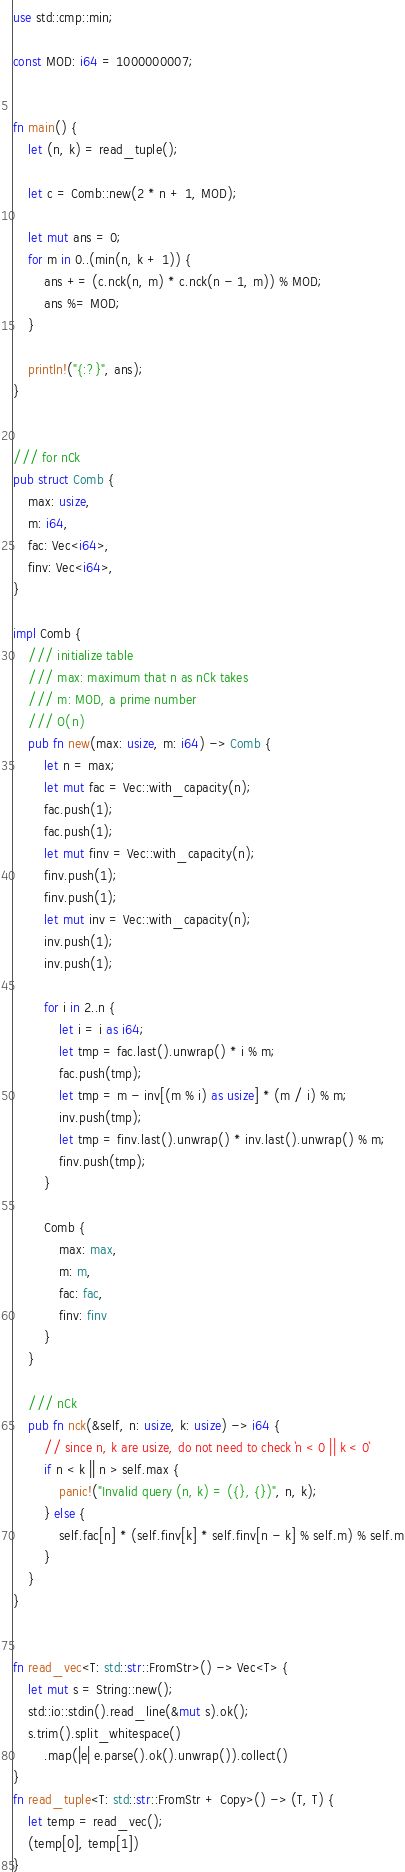<code> <loc_0><loc_0><loc_500><loc_500><_Rust_>use std::cmp::min;

const MOD: i64 = 1000000007;


fn main() {
    let (n, k) = read_tuple();

    let c = Comb::new(2 * n + 1, MOD);

    let mut ans = 0;
    for m in 0..(min(n, k + 1)) {
        ans += (c.nck(n, m) * c.nck(n - 1, m)) % MOD;
        ans %= MOD;
    }
    
    println!("{:?}", ans);
}


/// for nCk
pub struct Comb {
    max: usize,
    m: i64,
    fac: Vec<i64>,
    finv: Vec<i64>,
}

impl Comb {
    /// initialize table 
    /// max: maximum that n as nCk takes
    /// m: MOD, a prime number
    /// O(n)
    pub fn new(max: usize, m: i64) -> Comb {
        let n = max;
        let mut fac = Vec::with_capacity(n);
        fac.push(1);
        fac.push(1);
        let mut finv = Vec::with_capacity(n);
        finv.push(1);
        finv.push(1);
        let mut inv = Vec::with_capacity(n);
        inv.push(1);
        inv.push(1);

        for i in 2..n {
            let i = i as i64;
            let tmp = fac.last().unwrap() * i % m;
            fac.push(tmp);
            let tmp = m - inv[(m % i) as usize] * (m / i) % m;
            inv.push(tmp);
            let tmp = finv.last().unwrap() * inv.last().unwrap() % m;
            finv.push(tmp);
        }

        Comb {
            max: max,
            m: m,
            fac: fac,
            finv: finv
        }
    }

    /// nCk
    pub fn nck(&self, n: usize, k: usize) -> i64 {
        // since n, k are usize, do not need to check `n < 0 || k < 0`
        if n < k || n > self.max {
            panic!("Invalid query (n, k) = ({}, {})", n, k);
        } else {
            self.fac[n] * (self.finv[k] * self.finv[n - k] % self.m) % self.m
        }
    }
}


fn read_vec<T: std::str::FromStr>() -> Vec<T> {
    let mut s = String::new();
    std::io::stdin().read_line(&mut s).ok();
    s.trim().split_whitespace()
        .map(|e| e.parse().ok().unwrap()).collect()
}
fn read_tuple<T: std::str::FromStr + Copy>() -> (T, T) {
    let temp = read_vec();
    (temp[0], temp[1])
}

</code> 